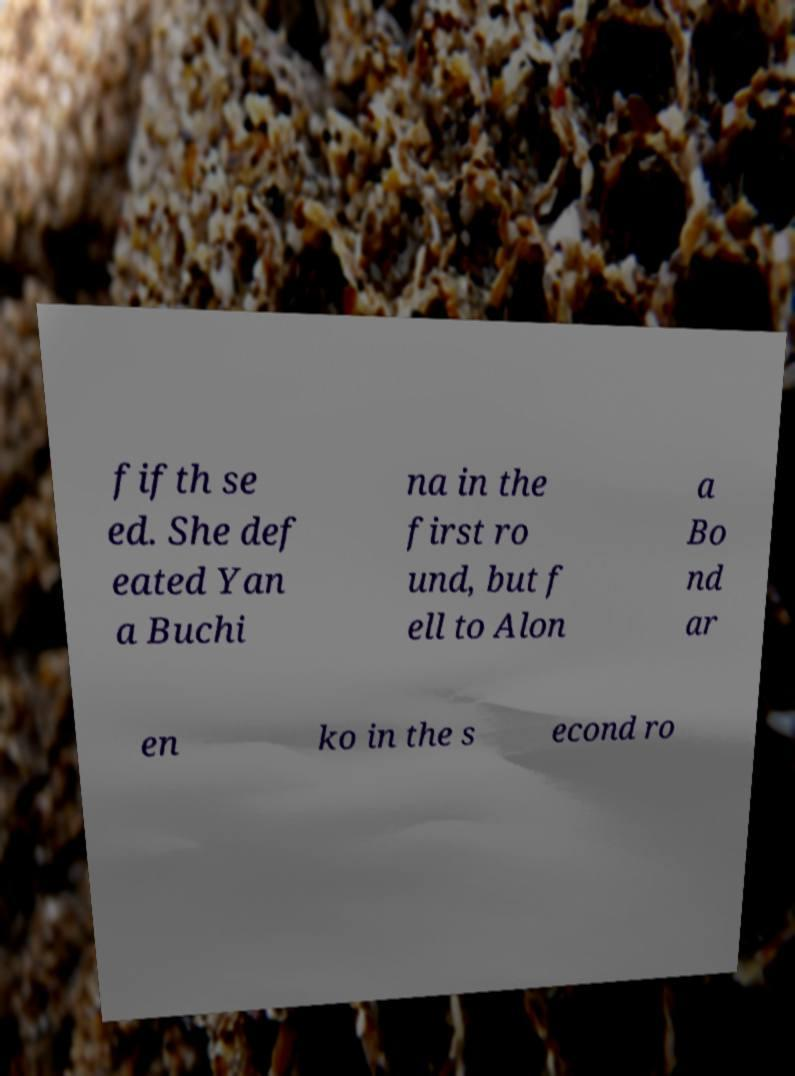For documentation purposes, I need the text within this image transcribed. Could you provide that? fifth se ed. She def eated Yan a Buchi na in the first ro und, but f ell to Alon a Bo nd ar en ko in the s econd ro 